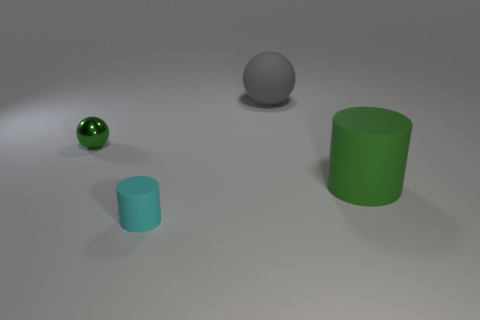There is a green matte object; how many green metal spheres are behind it?
Your answer should be compact. 1. Are there any large gray objects that have the same material as the big green thing?
Your answer should be very brief. Yes. There is a tiny metallic thing that is the same color as the large cylinder; what shape is it?
Your answer should be compact. Sphere. What color is the matte object on the left side of the gray rubber ball?
Ensure brevity in your answer.  Cyan. Are there an equal number of big objects that are on the right side of the big gray object and green cylinders that are in front of the small green object?
Provide a succinct answer. Yes. There is a big object that is behind the cylinder that is behind the cyan cylinder; what is it made of?
Keep it short and to the point. Rubber. What number of objects are cylinders or tiny things that are right of the metal object?
Offer a terse response. 2. There is a green cylinder that is the same material as the big gray ball; what size is it?
Offer a very short reply. Large. Are there more balls to the right of the tiny green sphere than small cyan rubber spheres?
Offer a terse response. Yes. What is the size of the matte object that is in front of the large sphere and behind the cyan matte object?
Offer a terse response. Large. 